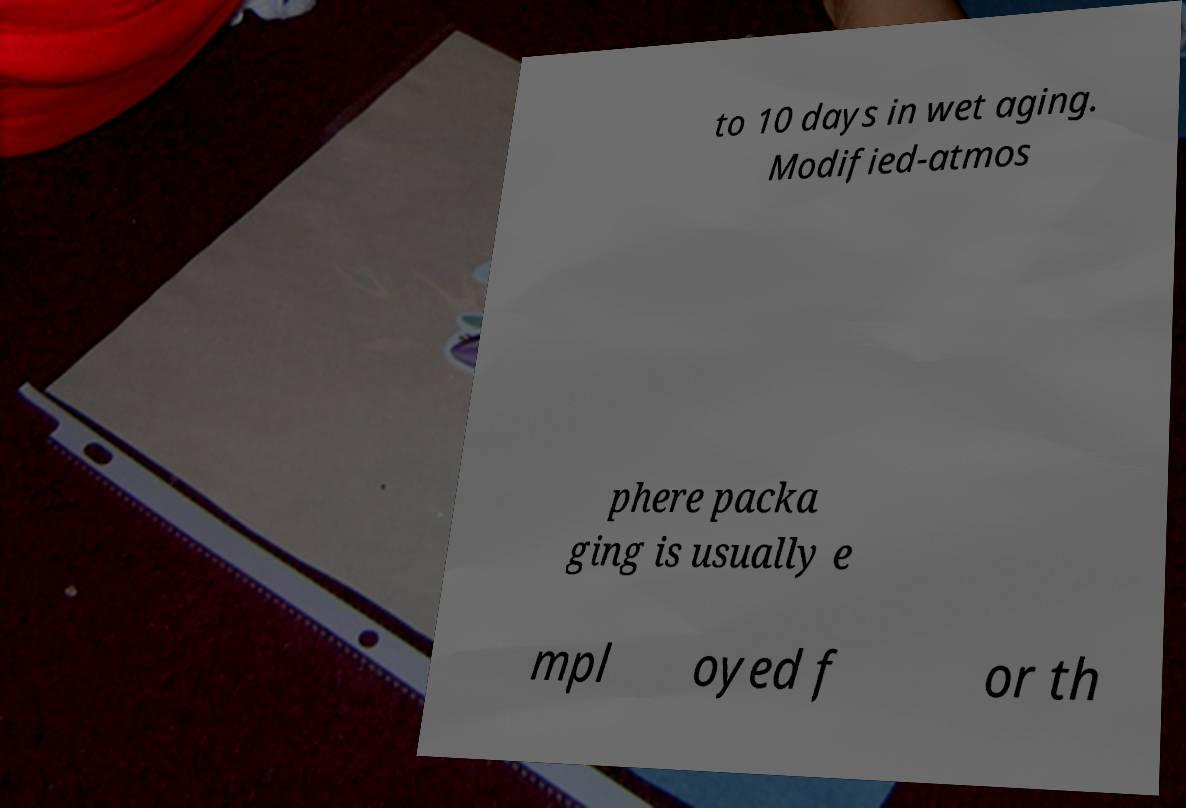There's text embedded in this image that I need extracted. Can you transcribe it verbatim? to 10 days in wet aging. Modified-atmos phere packa ging is usually e mpl oyed f or th 